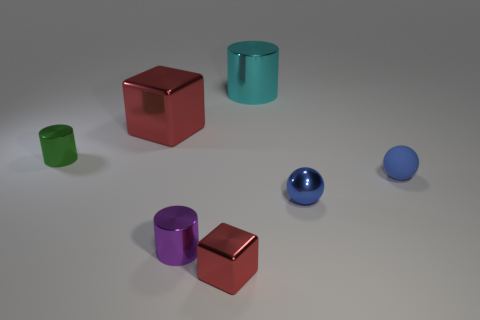Subtract all gray cubes. Subtract all yellow cylinders. How many cubes are left? 2 Add 3 small matte objects. How many objects exist? 10 Subtract all cylinders. How many objects are left? 4 Add 1 purple objects. How many purple objects are left? 2 Add 4 cyan cylinders. How many cyan cylinders exist? 5 Subtract 0 gray cylinders. How many objects are left? 7 Subtract all large cyan objects. Subtract all small brown balls. How many objects are left? 6 